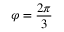Convert formula to latex. <formula><loc_0><loc_0><loc_500><loc_500>\varphi = \frac { 2 \pi } { 3 }</formula> 